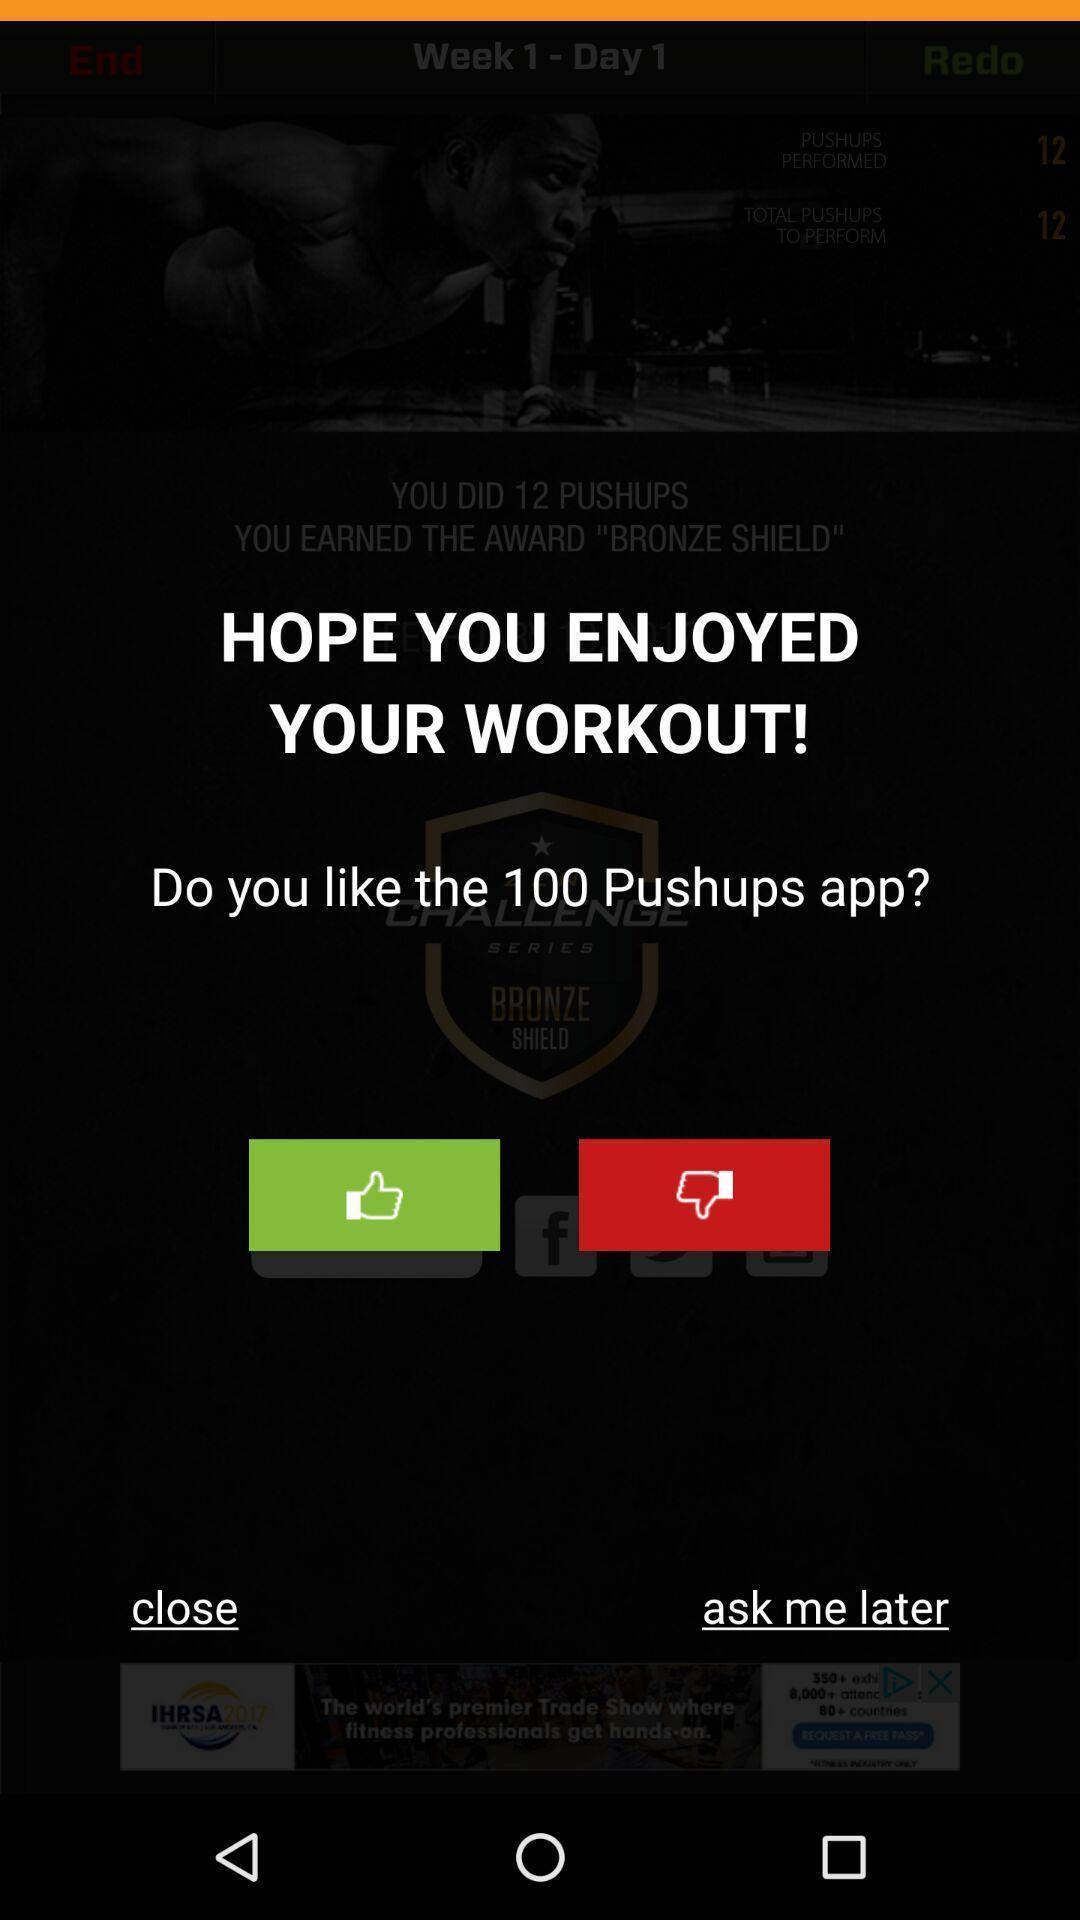Please provide a description for this image. Page showing about feedback of app. 